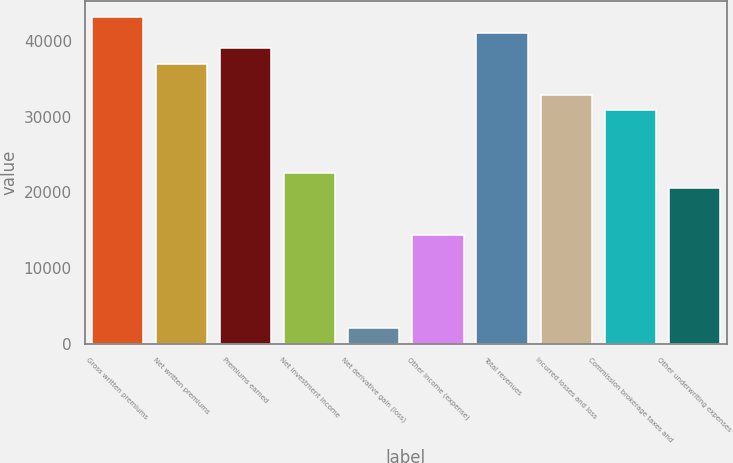Convert chart to OTSL. <chart><loc_0><loc_0><loc_500><loc_500><bar_chart><fcel>Gross written premiums<fcel>Net written premiums<fcel>Premiums earned<fcel>Net investment income<fcel>Net derivative gain (loss)<fcel>Other income (expense)<fcel>Total revenues<fcel>Incurred losses and loss<fcel>Commission brokerage taxes and<fcel>Other underwriting expenses<nl><fcel>43140.1<fcel>36977.9<fcel>39031.9<fcel>22599.5<fcel>2058.86<fcel>14383.2<fcel>41086<fcel>32869.8<fcel>30815.7<fcel>20545.4<nl></chart> 